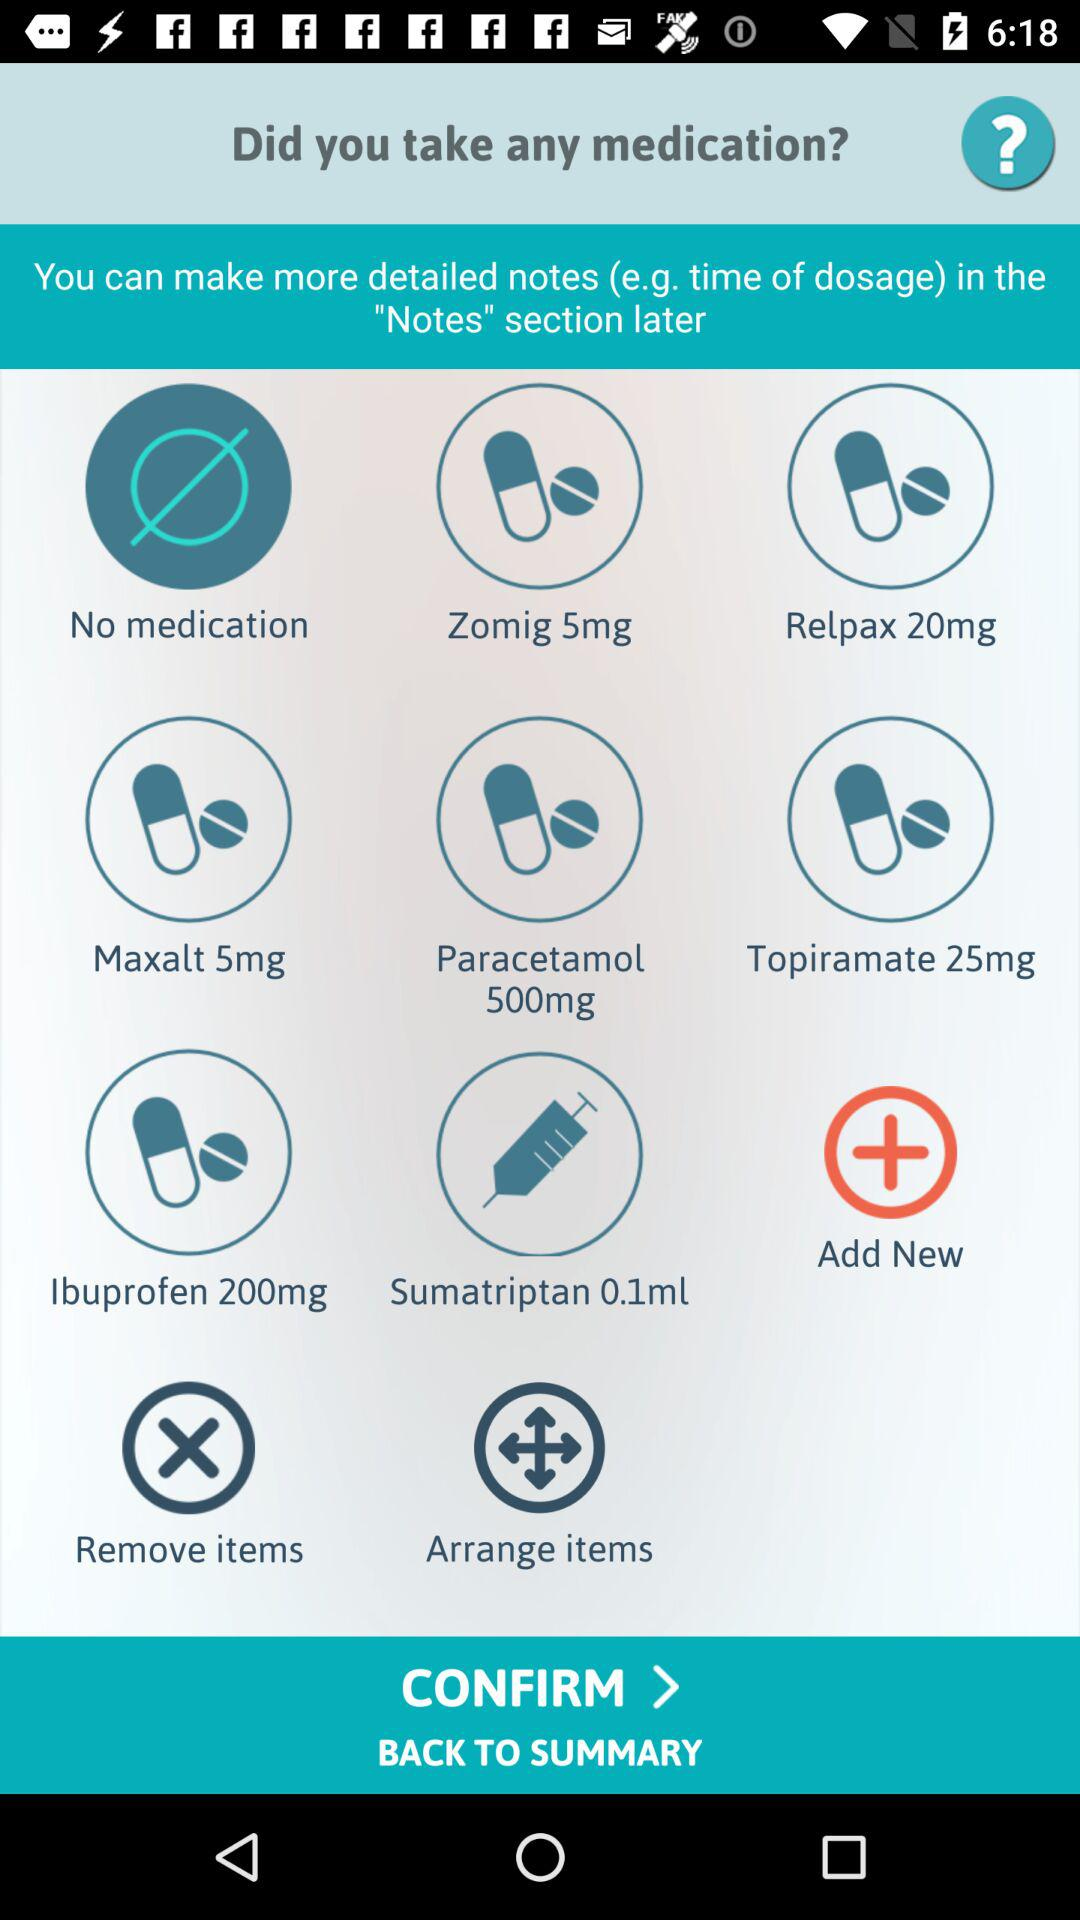How many of the medications are in liquid form?
Answer the question using a single word or phrase. 1 